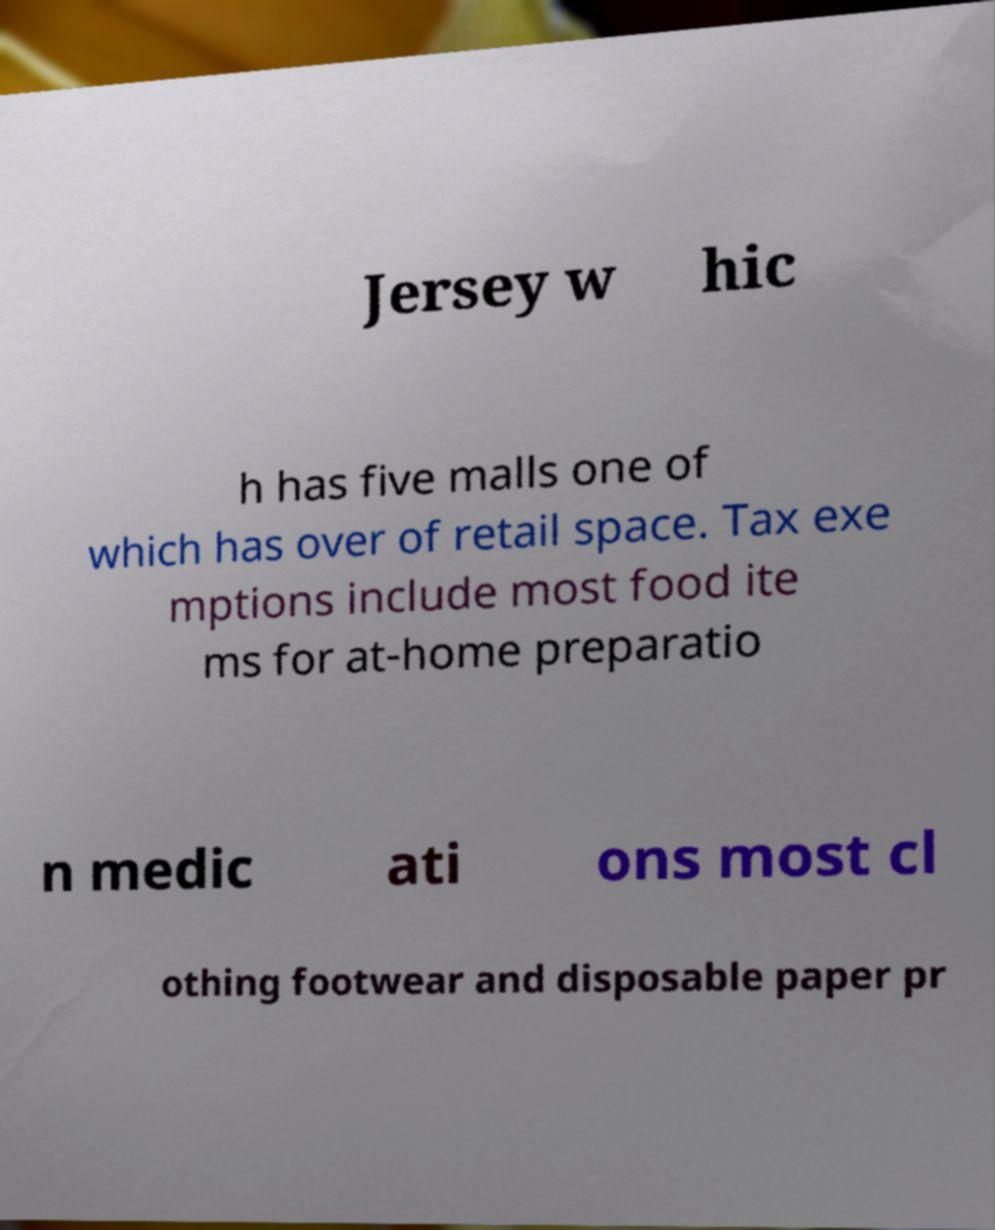What messages or text are displayed in this image? I need them in a readable, typed format. Jersey w hic h has five malls one of which has over of retail space. Tax exe mptions include most food ite ms for at-home preparatio n medic ati ons most cl othing footwear and disposable paper pr 